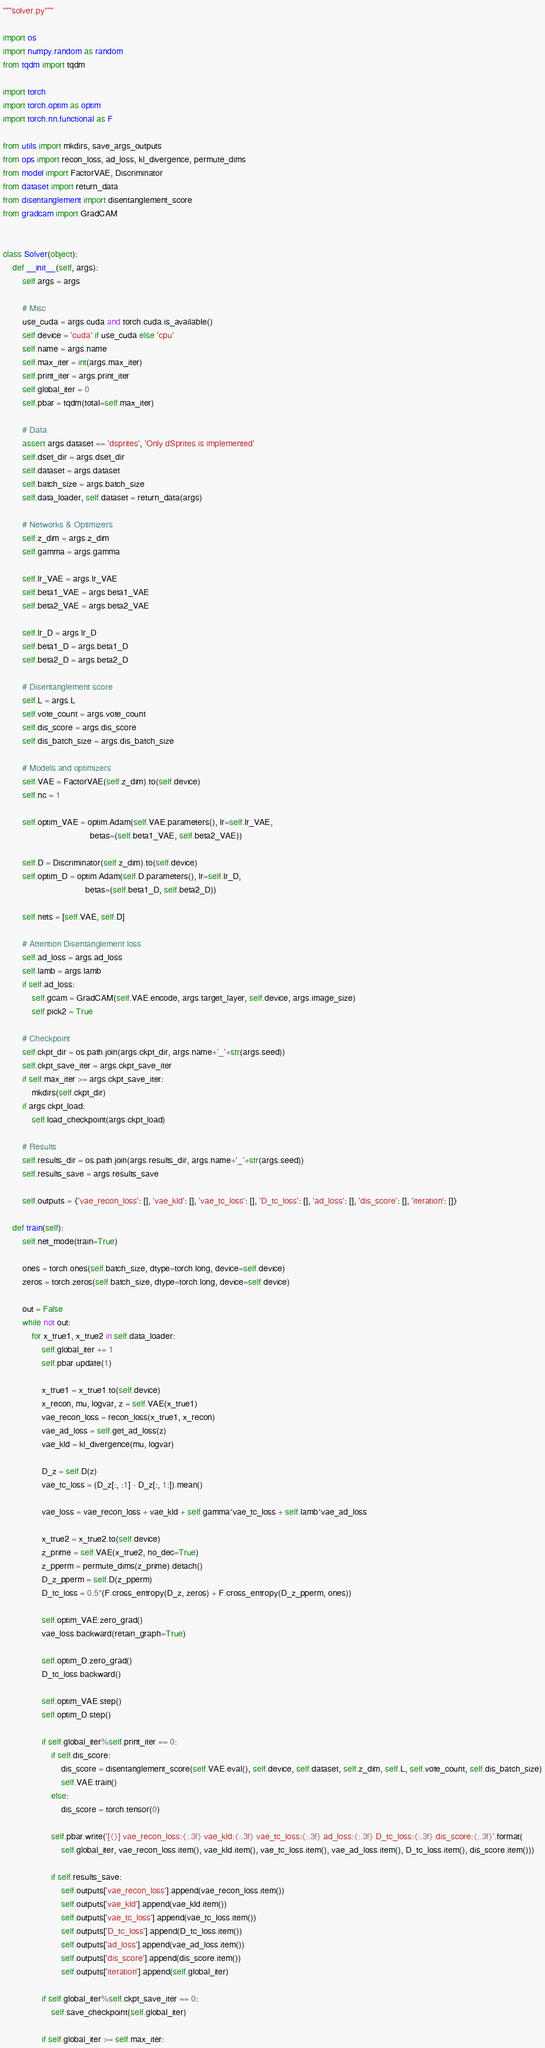<code> <loc_0><loc_0><loc_500><loc_500><_Python_>"""solver.py"""

import os
import numpy.random as random
from tqdm import tqdm

import torch
import torch.optim as optim
import torch.nn.functional as F

from utils import mkdirs, save_args_outputs
from ops import recon_loss, ad_loss, kl_divergence, permute_dims
from model import FactorVAE, Discriminator
from dataset import return_data
from disentanglement import disentanglement_score
from gradcam import GradCAM


class Solver(object):
    def __init__(self, args):
        self.args = args

        # Misc
        use_cuda = args.cuda and torch.cuda.is_available()
        self.device = 'cuda' if use_cuda else 'cpu'
        self.name = args.name
        self.max_iter = int(args.max_iter)
        self.print_iter = args.print_iter
        self.global_iter = 0
        self.pbar = tqdm(total=self.max_iter)

        # Data
        assert args.dataset == 'dsprites', 'Only dSprites is implemented'
        self.dset_dir = args.dset_dir
        self.dataset = args.dataset
        self.batch_size = args.batch_size
        self.data_loader, self.dataset = return_data(args)

        # Networks & Optimizers
        self.z_dim = args.z_dim
        self.gamma = args.gamma

        self.lr_VAE = args.lr_VAE
        self.beta1_VAE = args.beta1_VAE
        self.beta2_VAE = args.beta2_VAE

        self.lr_D = args.lr_D
        self.beta1_D = args.beta1_D
        self.beta2_D = args.beta2_D

        # Disentanglement score
        self.L = args.L
        self.vote_count = args.vote_count
        self.dis_score = args.dis_score
        self.dis_batch_size = args.dis_batch_size

        # Models and optimizers
        self.VAE = FactorVAE(self.z_dim).to(self.device)
        self.nc = 1

        self.optim_VAE = optim.Adam(self.VAE.parameters(), lr=self.lr_VAE,
                                    betas=(self.beta1_VAE, self.beta2_VAE))

        self.D = Discriminator(self.z_dim).to(self.device)
        self.optim_D = optim.Adam(self.D.parameters(), lr=self.lr_D,
                                  betas=(self.beta1_D, self.beta2_D))

        self.nets = [self.VAE, self.D]

        # Attention Disentanglement loss
        self.ad_loss = args.ad_loss
        self.lamb = args.lamb
        if self.ad_loss:
            self.gcam = GradCAM(self.VAE.encode, args.target_layer, self.device, args.image_size)
            self.pick2 = True

        # Checkpoint
        self.ckpt_dir = os.path.join(args.ckpt_dir, args.name+'_'+str(args.seed))
        self.ckpt_save_iter = args.ckpt_save_iter
        if self.max_iter >= args.ckpt_save_iter:
            mkdirs(self.ckpt_dir)
        if args.ckpt_load:
            self.load_checkpoint(args.ckpt_load)

        # Results
        self.results_dir = os.path.join(args.results_dir, args.name+'_'+str(args.seed))
        self.results_save = args.results_save

        self.outputs = {'vae_recon_loss': [], 'vae_kld': [], 'vae_tc_loss': [], 'D_tc_loss': [], 'ad_loss': [], 'dis_score': [], 'iteration': []}

    def train(self):
        self.net_mode(train=True)

        ones = torch.ones(self.batch_size, dtype=torch.long, device=self.device)
        zeros = torch.zeros(self.batch_size, dtype=torch.long, device=self.device)

        out = False
        while not out:
            for x_true1, x_true2 in self.data_loader:
                self.global_iter += 1
                self.pbar.update(1)

                x_true1 = x_true1.to(self.device)
                x_recon, mu, logvar, z = self.VAE(x_true1)
                vae_recon_loss = recon_loss(x_true1, x_recon)
                vae_ad_loss = self.get_ad_loss(z)
                vae_kld = kl_divergence(mu, logvar)

                D_z = self.D(z)
                vae_tc_loss = (D_z[:, :1] - D_z[:, 1:]).mean()

                vae_loss = vae_recon_loss + vae_kld + self.gamma*vae_tc_loss + self.lamb*vae_ad_loss

                x_true2 = x_true2.to(self.device)
                z_prime = self.VAE(x_true2, no_dec=True)
                z_pperm = permute_dims(z_prime).detach()
                D_z_pperm = self.D(z_pperm)
                D_tc_loss = 0.5*(F.cross_entropy(D_z, zeros) + F.cross_entropy(D_z_pperm, ones))

                self.optim_VAE.zero_grad()
                vae_loss.backward(retain_graph=True)

                self.optim_D.zero_grad()
                D_tc_loss.backward()

                self.optim_VAE.step()
                self.optim_D.step()

                if self.global_iter%self.print_iter == 0:
                    if self.dis_score:
                        dis_score = disentanglement_score(self.VAE.eval(), self.device, self.dataset, self.z_dim, self.L, self.vote_count, self.dis_batch_size)
                        self.VAE.train()
                    else:
                        dis_score = torch.tensor(0)

                    self.pbar.write('[{}] vae_recon_loss:{:.3f} vae_kld:{:.3f} vae_tc_loss:{:.3f} ad_loss:{:.3f} D_tc_loss:{:.3f} dis_score:{:.3f}'.format(
                        self.global_iter, vae_recon_loss.item(), vae_kld.item(), vae_tc_loss.item(), vae_ad_loss.item(), D_tc_loss.item(), dis_score.item()))

                    if self.results_save:
                        self.outputs['vae_recon_loss'].append(vae_recon_loss.item())
                        self.outputs['vae_kld'].append(vae_kld.item())
                        self.outputs['vae_tc_loss'].append(vae_tc_loss.item())
                        self.outputs['D_tc_loss'].append(D_tc_loss.item())
                        self.outputs['ad_loss'].append(vae_ad_loss.item())
                        self.outputs['dis_score'].append(dis_score.item())
                        self.outputs['iteration'].append(self.global_iter)

                if self.global_iter%self.ckpt_save_iter == 0:
                    self.save_checkpoint(self.global_iter)

                if self.global_iter >= self.max_iter:</code> 